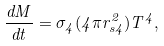<formula> <loc_0><loc_0><loc_500><loc_500>\frac { d M } { d t } = \sigma _ { 4 } ( 4 \pi r _ { s 4 } ^ { 2 } ) T ^ { 4 } ,</formula> 